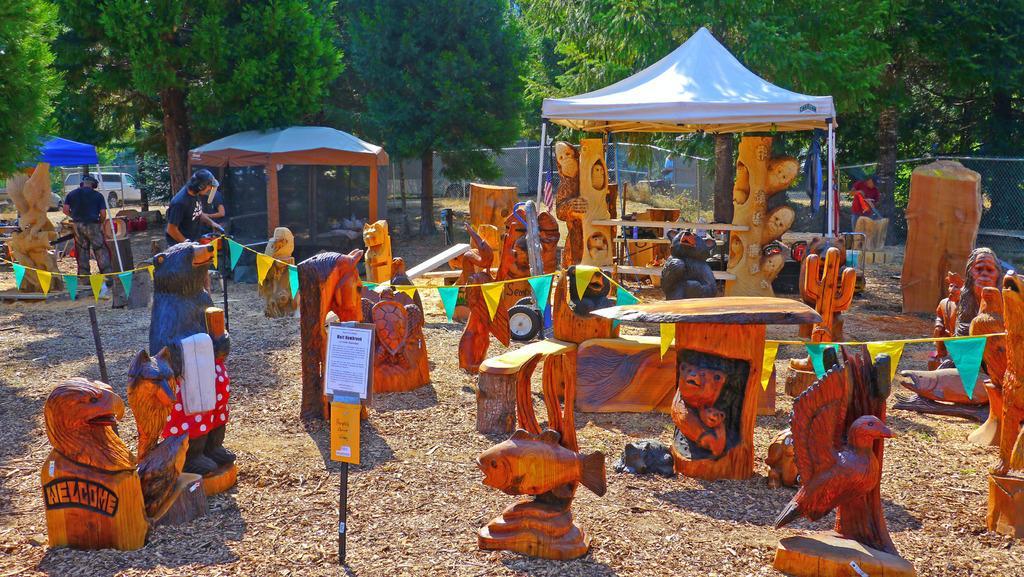Describe this image in one or two sentences. In this image there are some sculptures and some persons, and in the foreground there is a pole and some boards. At the bottom there is sand, and in the background there are some tents, trees, vehicle, net and some other objects. 